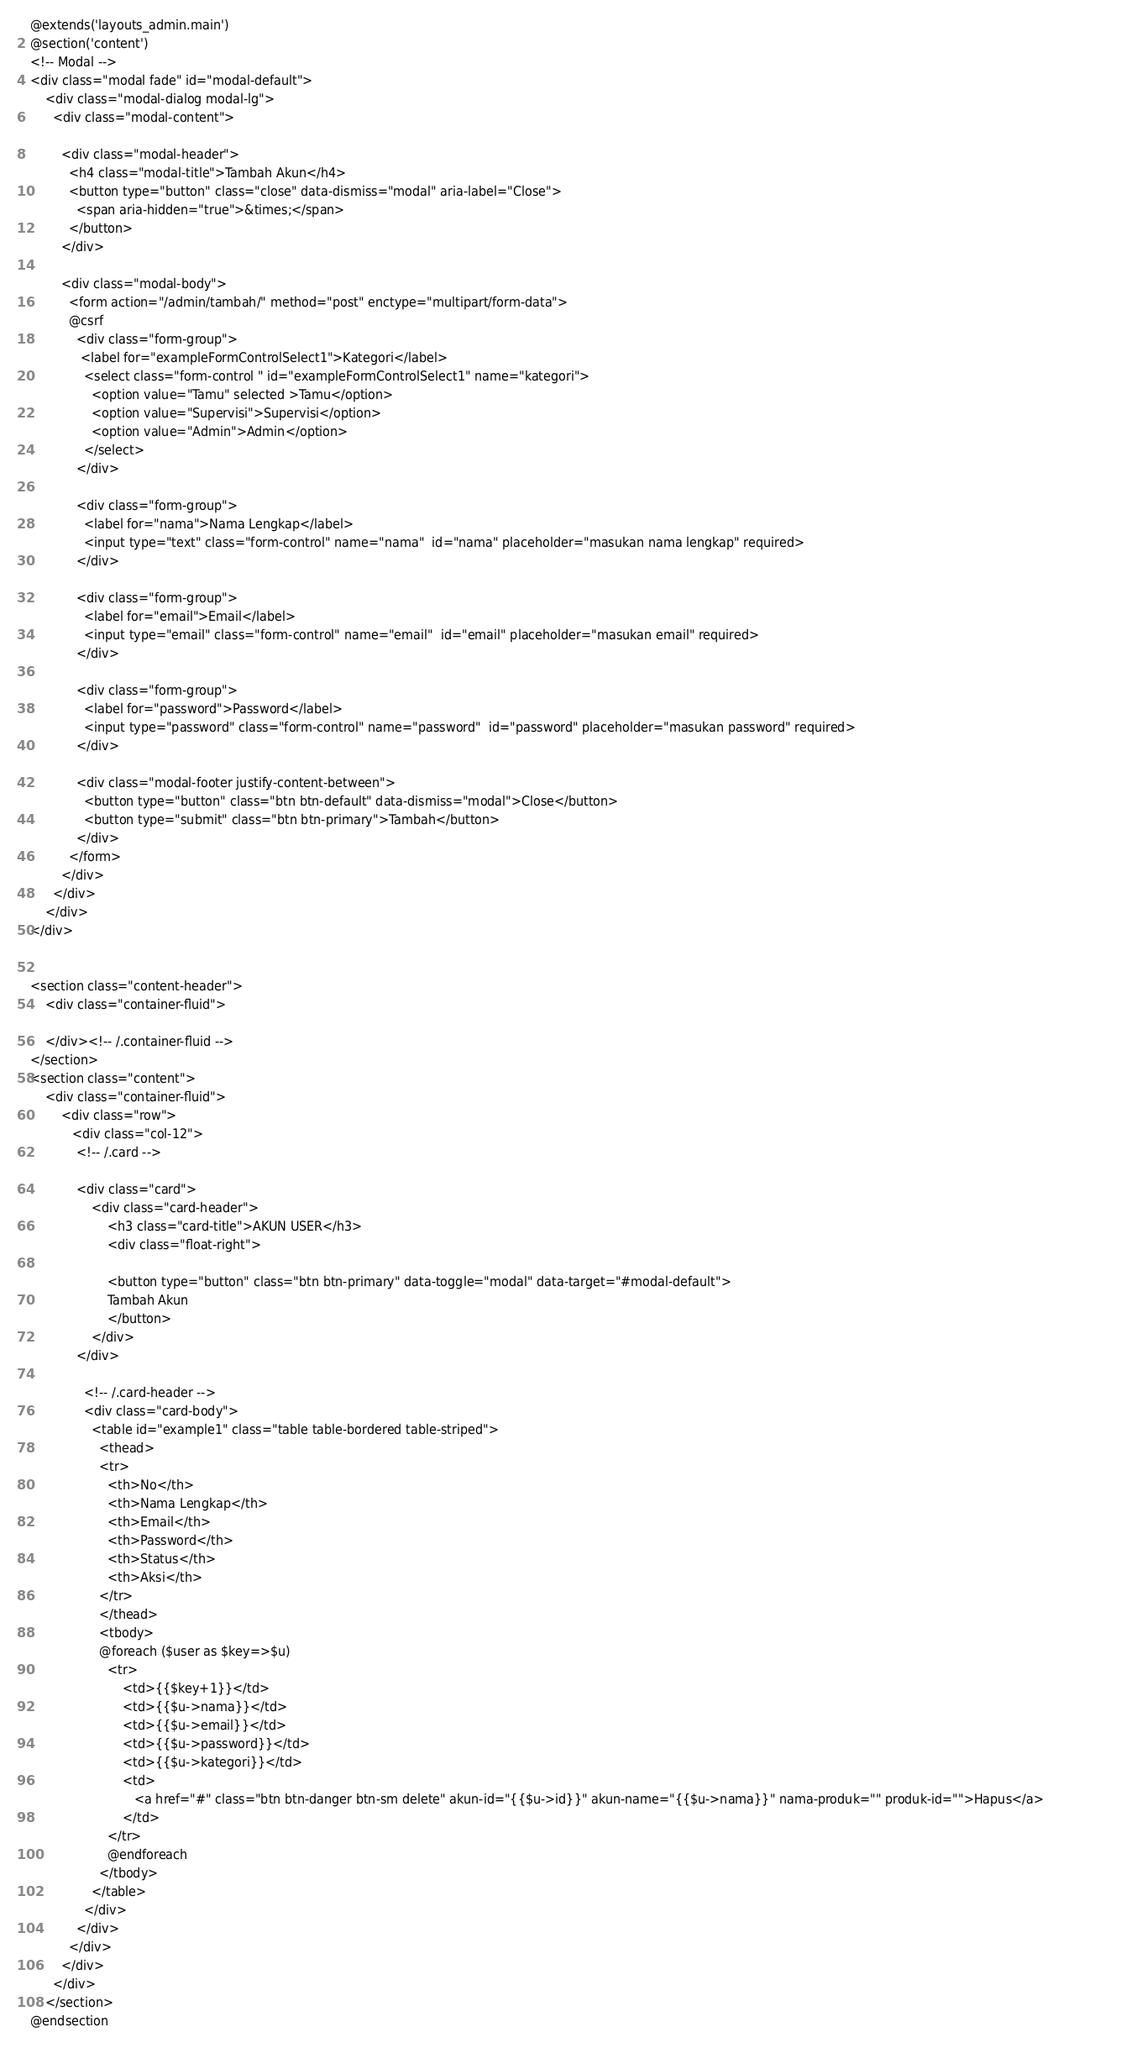Convert code to text. <code><loc_0><loc_0><loc_500><loc_500><_PHP_>@extends('layouts_admin.main')
@section('content')
<!-- Modal -->
<div class="modal fade" id="modal-default">
    <div class="modal-dialog modal-lg">
      <div class="modal-content">

        <div class="modal-header">
          <h4 class="modal-title">Tambah Akun</h4>
          <button type="button" class="close" data-dismiss="modal" aria-label="Close">
            <span aria-hidden="true">&times;</span>
          </button>
        </div>

        <div class="modal-body">            
          <form action="/admin/tambah/" method="post" enctype="multipart/form-data">
          @csrf
            <div class="form-group">
             <label for="exampleFormControlSelect1">Kategori</label>
              <select class="form-control " id="exampleFormControlSelect1" name="kategori">
                <option value="Tamu" selected >Tamu</option>
                <option value="Supervisi">Supervisi</option>
                <option value="Admin">Admin</option>
              </select>
            </div>

            <div class="form-group">
              <label for="nama">Nama Lengkap</label>
              <input type="text" class="form-control" name="nama"  id="nama" placeholder="masukan nama lengkap" required>
            </div>

            <div class="form-group">
              <label for="email">Email</label>
              <input type="email" class="form-control" name="email"  id="email" placeholder="masukan email" required>
            </div>

            <div class="form-group">
              <label for="password">Password</label>
              <input type="password" class="form-control" name="password"  id="password" placeholder="masukan password" required>
            </div>

            <div class="modal-footer justify-content-between">
              <button type="button" class="btn btn-default" data-dismiss="modal">Close</button>
              <button type="submit" class="btn btn-primary">Tambah</button>  
            </div>
          </form>
        </div>
      </div>
    </div>
</div>


<section class="content-header">
    <div class="container-fluid">

    </div><!-- /.container-fluid -->
</section>
<section class="content">
    <div class="container-fluid">
        <div class="row">
           <div class="col-12">
            <!-- /.card -->

            <div class="card">
                <div class="card-header">
                    <h3 class="card-title">AKUN USER</h3>
                    <div class="float-right">

                    <button type="button" class="btn btn-primary" data-toggle="modal" data-target="#modal-default">
                    Tambah Akun
                    </button>
                </div>
            </div>
              
              <!-- /.card-header -->
              <div class="card-body">
                <table id="example1" class="table table-bordered table-striped">
                  <thead>
                  <tr>
                    <th>No</th>
                    <th>Nama Lengkap</th>
                    <th>Email</th>
                    <th>Password</th>
                    <th>Status</th>
                    <th>Aksi</th>
                  </tr>
                  </thead>
                  <tbody>
                  @foreach ($user as $key=>$u)
                    <tr>
                        <td>{{$key+1}}</td>
                        <td>{{$u->nama}}</td>
                        <td>{{$u->email}}</td>
                        <td>{{$u->password}}</td>
                        <td>{{$u->kategori}}</td>
                        <td>
                           <a href="#" class="btn btn-danger btn-sm delete" akun-id="{{$u->id}}" akun-name="{{$u->nama}}" nama-produk="" produk-id="">Hapus</a>                 
                        </td>
                    </tr>  
                    @endforeach            
                  </tbody>
                </table>
              </div>
            </div>
          </div>
        </div>
      </div>
    </section>
@endsection</code> 